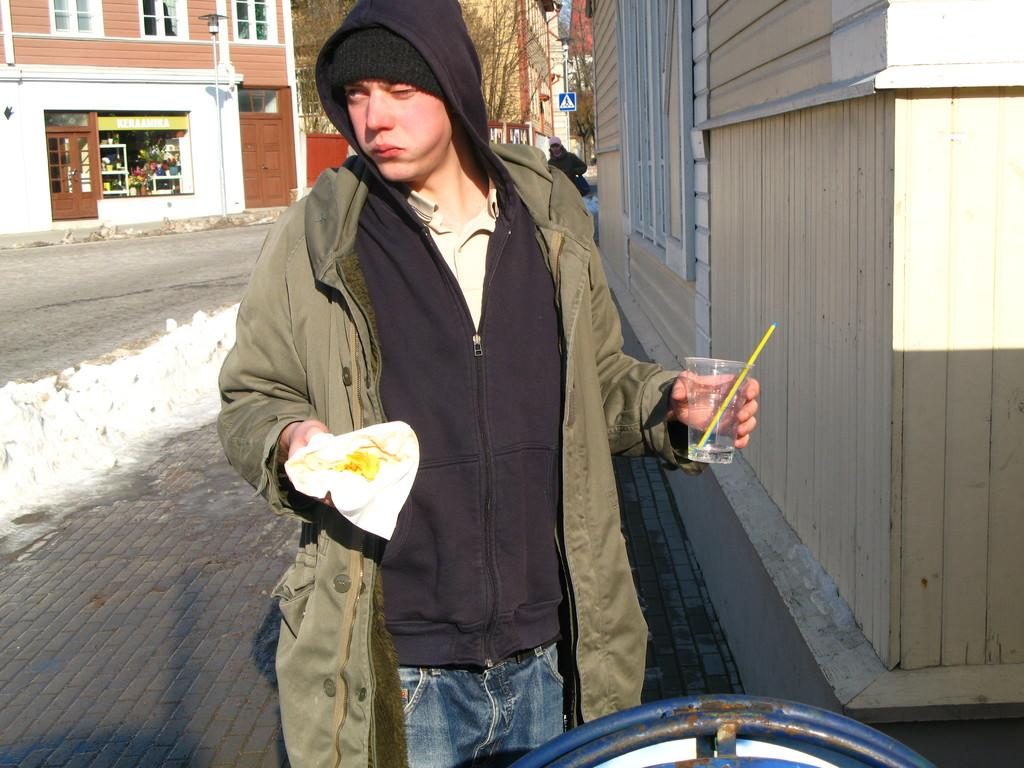What is the main subject of the image? There is a person standing in the center of the image. What is the person holding in their hands? The person is holding a glass and a cloth. What can be seen in the background of the image? There are buildings, trees, windows, a pole, and sign boards in the background of the image. How many dimes are visible on the person's stocking in the image? There are no dimes or stockings visible on the person in the image. What type of horse can be seen grazing in the background of the image? There is no horse present in the image; the background features buildings, trees, windows, a pole, and sign boards. 